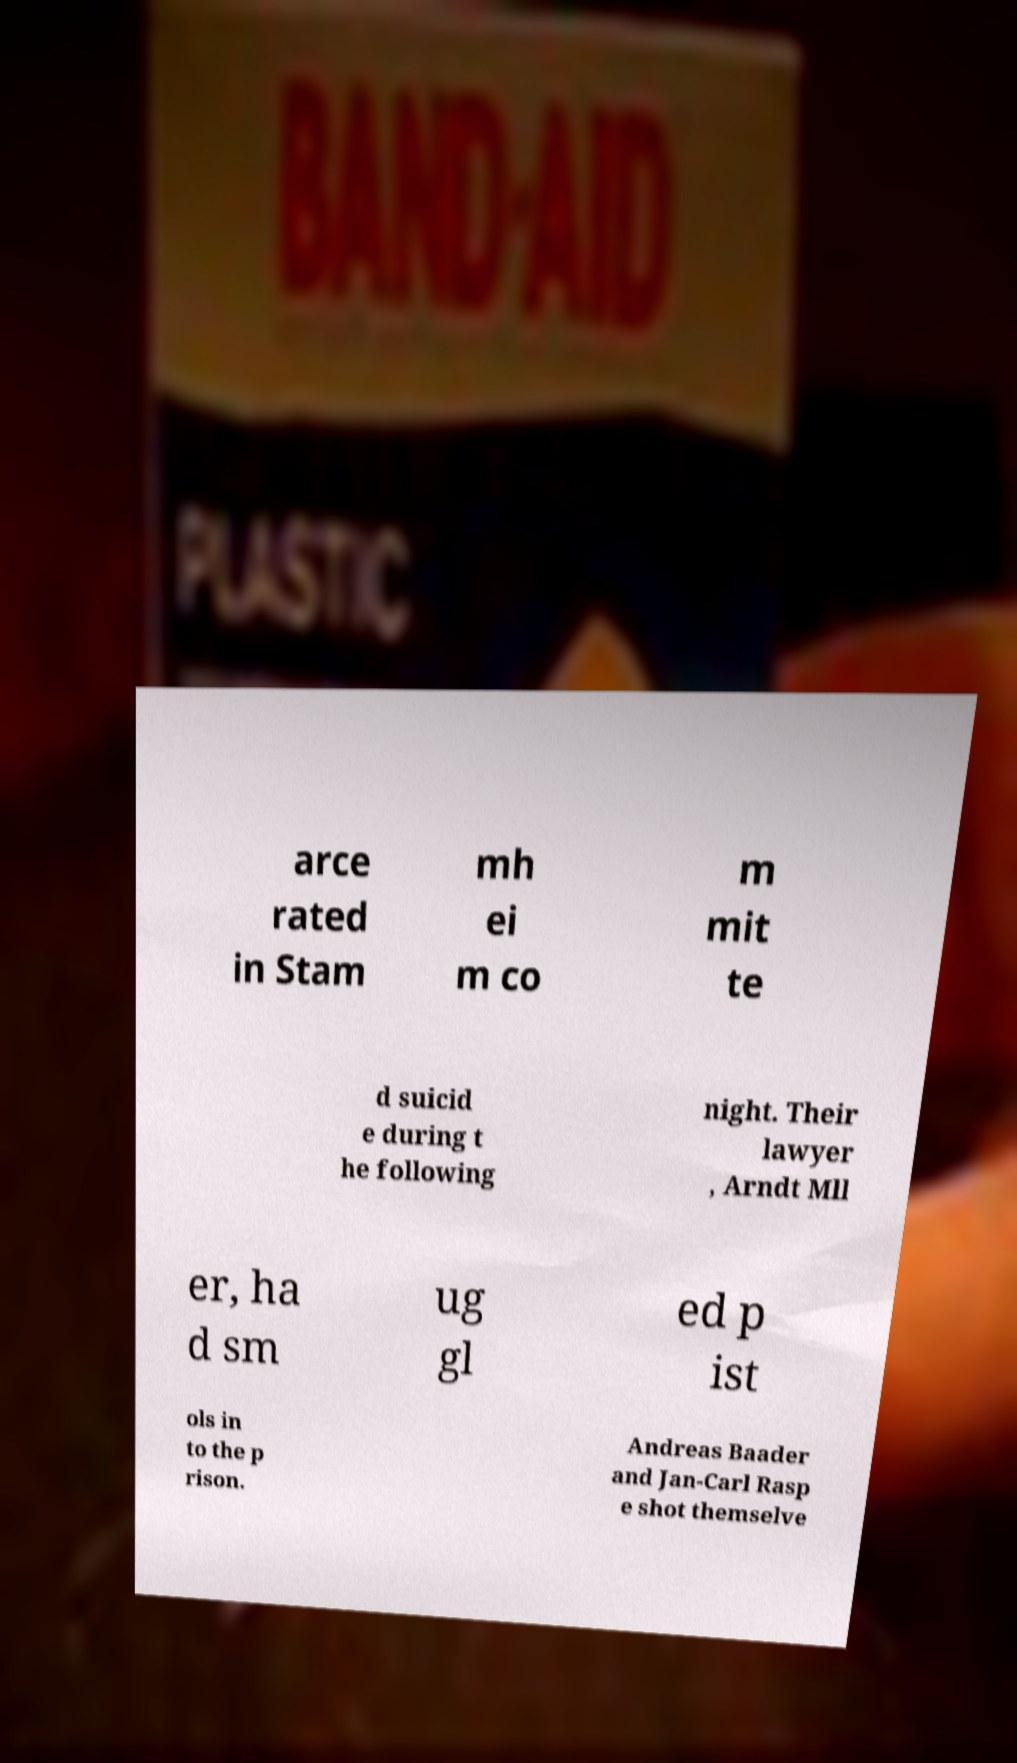Please read and relay the text visible in this image. What does it say? arce rated in Stam mh ei m co m mit te d suicid e during t he following night. Their lawyer , Arndt Mll er, ha d sm ug gl ed p ist ols in to the p rison. Andreas Baader and Jan-Carl Rasp e shot themselve 